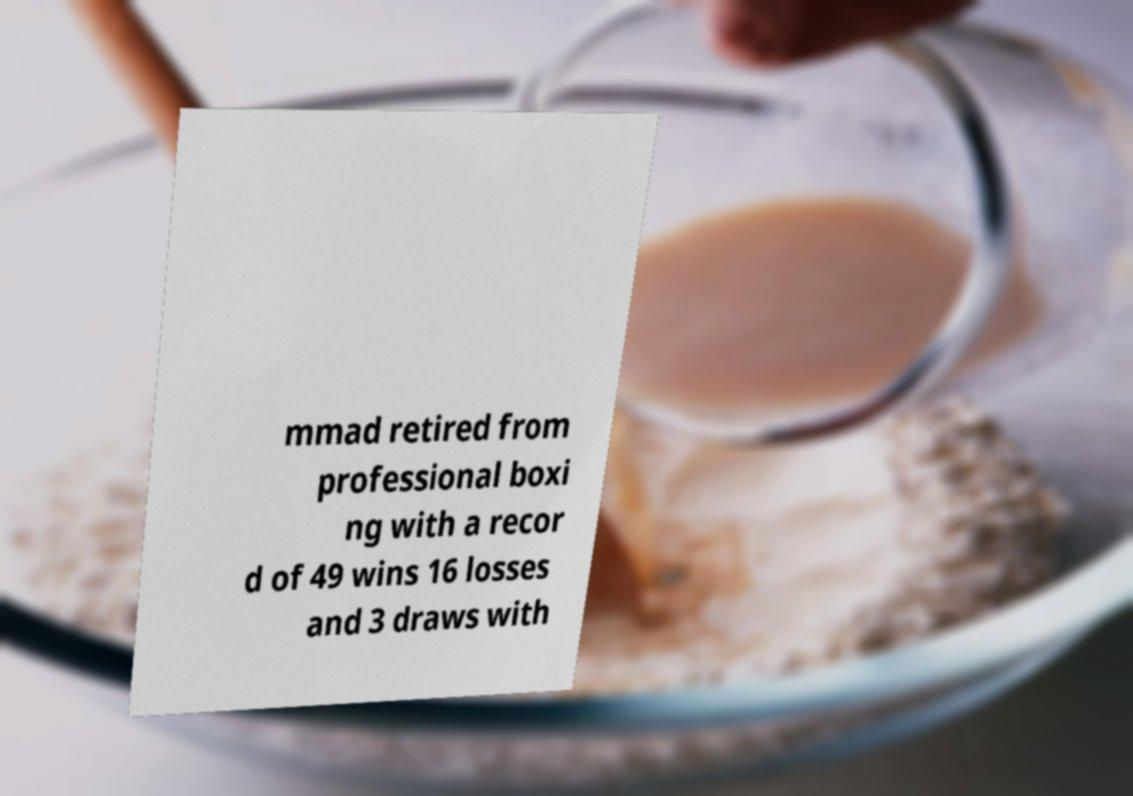Can you accurately transcribe the text from the provided image for me? mmad retired from professional boxi ng with a recor d of 49 wins 16 losses and 3 draws with 